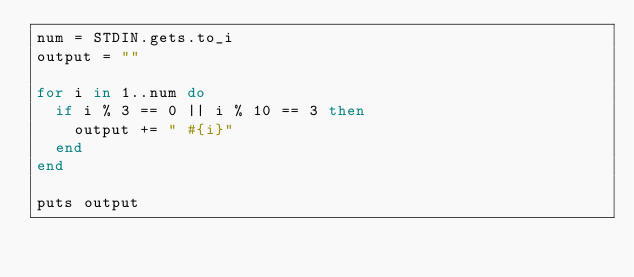Convert code to text. <code><loc_0><loc_0><loc_500><loc_500><_Ruby_>num = STDIN.gets.to_i
output = ""

for i in 1..num do
  if i % 3 == 0 || i % 10 == 3 then
    output += " #{i}"
  end
end

puts output</code> 